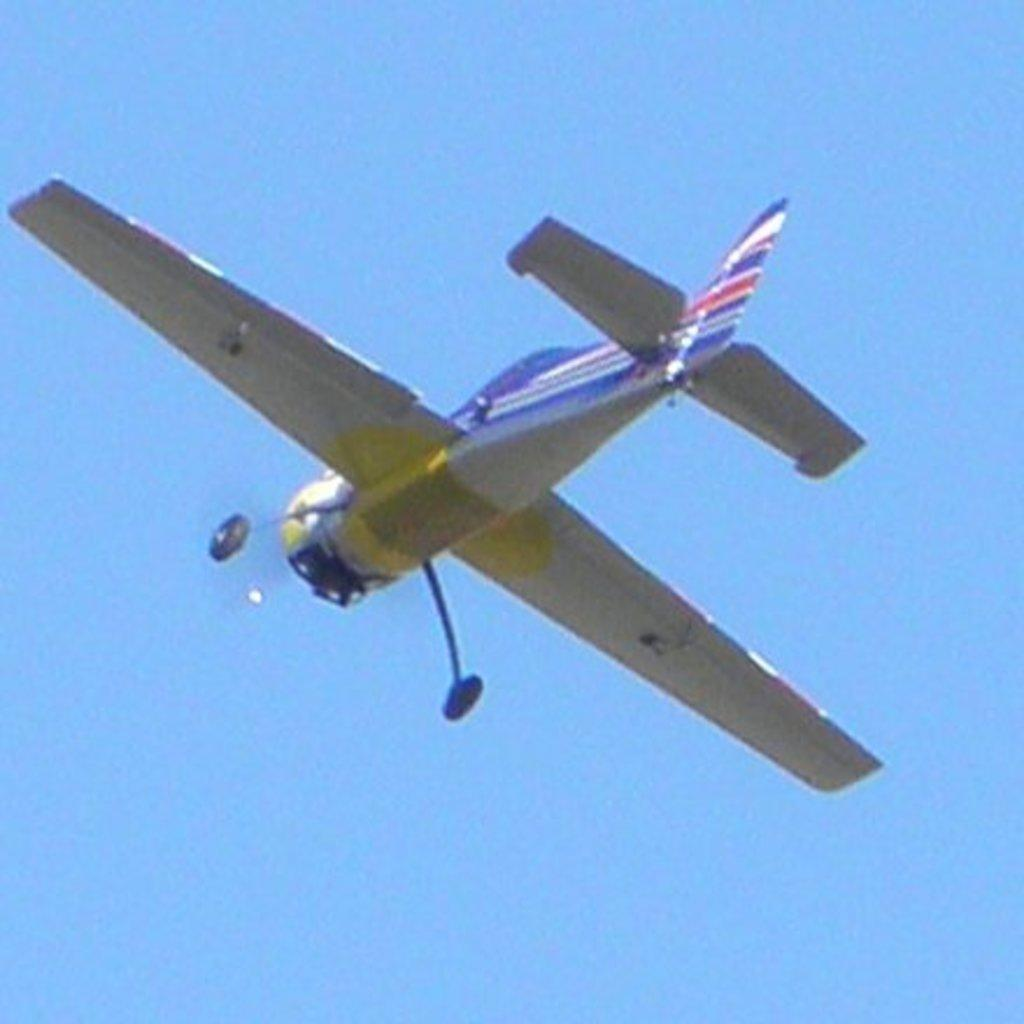What is the main subject of the image? The main subject of the image is an airplane. What is the airplane doing in the image? The airplane is flying in the sky. How much payment is required to enter the airplane's mind in the image? There is no mention of payment or the airplane's mind in the image; it simply shows an airplane flying in the sky. 